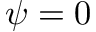<formula> <loc_0><loc_0><loc_500><loc_500>\psi = 0</formula> 